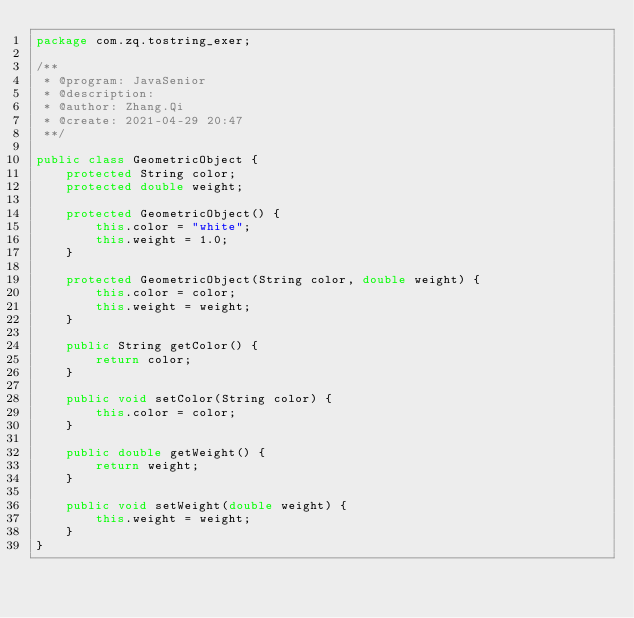<code> <loc_0><loc_0><loc_500><loc_500><_Java_>package com.zq.tostring_exer;

/**
 * @program: JavaSenior
 * @description:
 * @author: Zhang.Qi
 * @create: 2021-04-29 20:47
 **/

public class GeometricObject {
    protected String color;
    protected double weight;

    protected GeometricObject() {
        this.color = "white";
        this.weight = 1.0;
    }

    protected GeometricObject(String color, double weight) {
        this.color = color;
        this.weight = weight;
    }

    public String getColor() {
        return color;
    }

    public void setColor(String color) {
        this.color = color;
    }

    public double getWeight() {
        return weight;
    }

    public void setWeight(double weight) {
        this.weight = weight;
    }
}
</code> 